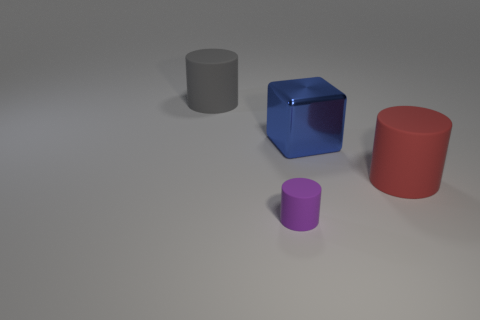The gray rubber thing that is the same size as the blue block is what shape?
Make the answer very short. Cylinder. The metallic cube has what size?
Your response must be concise. Large. What is the material of the large cylinder that is on the left side of the big matte thing in front of the matte thing behind the blue block?
Give a very brief answer. Rubber. The large cylinder that is made of the same material as the large red object is what color?
Your answer should be very brief. Gray. There is a cylinder in front of the large cylinder right of the large gray object; what number of blue metallic objects are behind it?
Provide a succinct answer. 1. Are there any other things that have the same shape as the purple matte thing?
Your response must be concise. Yes. What number of objects are matte cylinders that are in front of the large blue block or purple matte cylinders?
Give a very brief answer. 2. There is a rubber object behind the metal thing; does it have the same color as the tiny object?
Your answer should be very brief. No. There is a big blue object that is to the left of the red rubber cylinder that is right of the blue thing; what is its shape?
Provide a short and direct response. Cube. Are there fewer tiny things to the right of the large blue object than big gray cylinders in front of the large gray cylinder?
Ensure brevity in your answer.  No. 